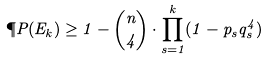<formula> <loc_0><loc_0><loc_500><loc_500>\P P ( E _ { k } ) \geq 1 - \binom { n } { 4 } \cdot \prod _ { s = 1 } ^ { k } ( 1 - p _ { s } q _ { s } ^ { 4 } )</formula> 